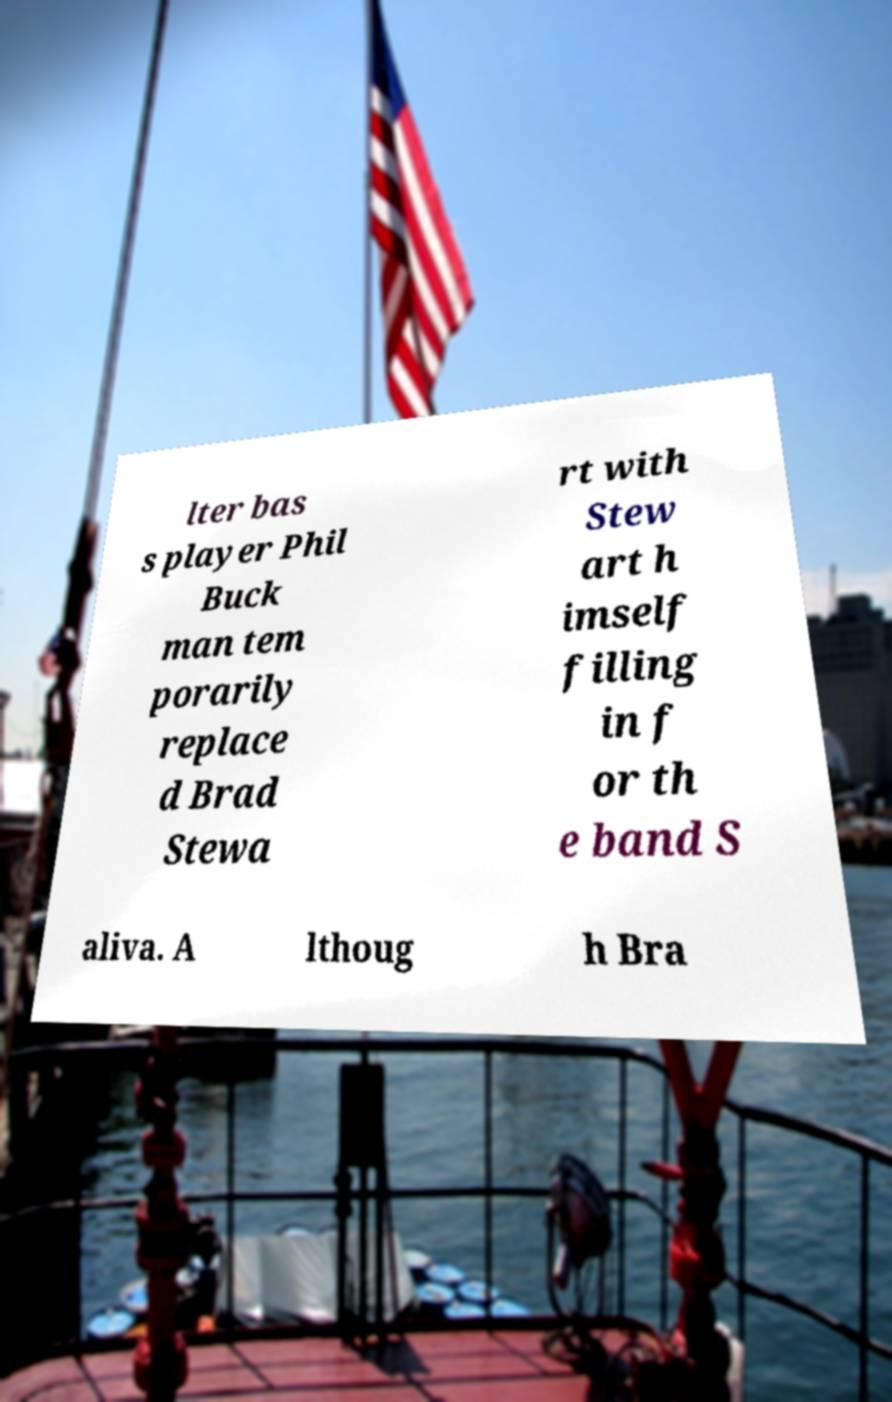Please read and relay the text visible in this image. What does it say? lter bas s player Phil Buck man tem porarily replace d Brad Stewa rt with Stew art h imself filling in f or th e band S aliva. A lthoug h Bra 